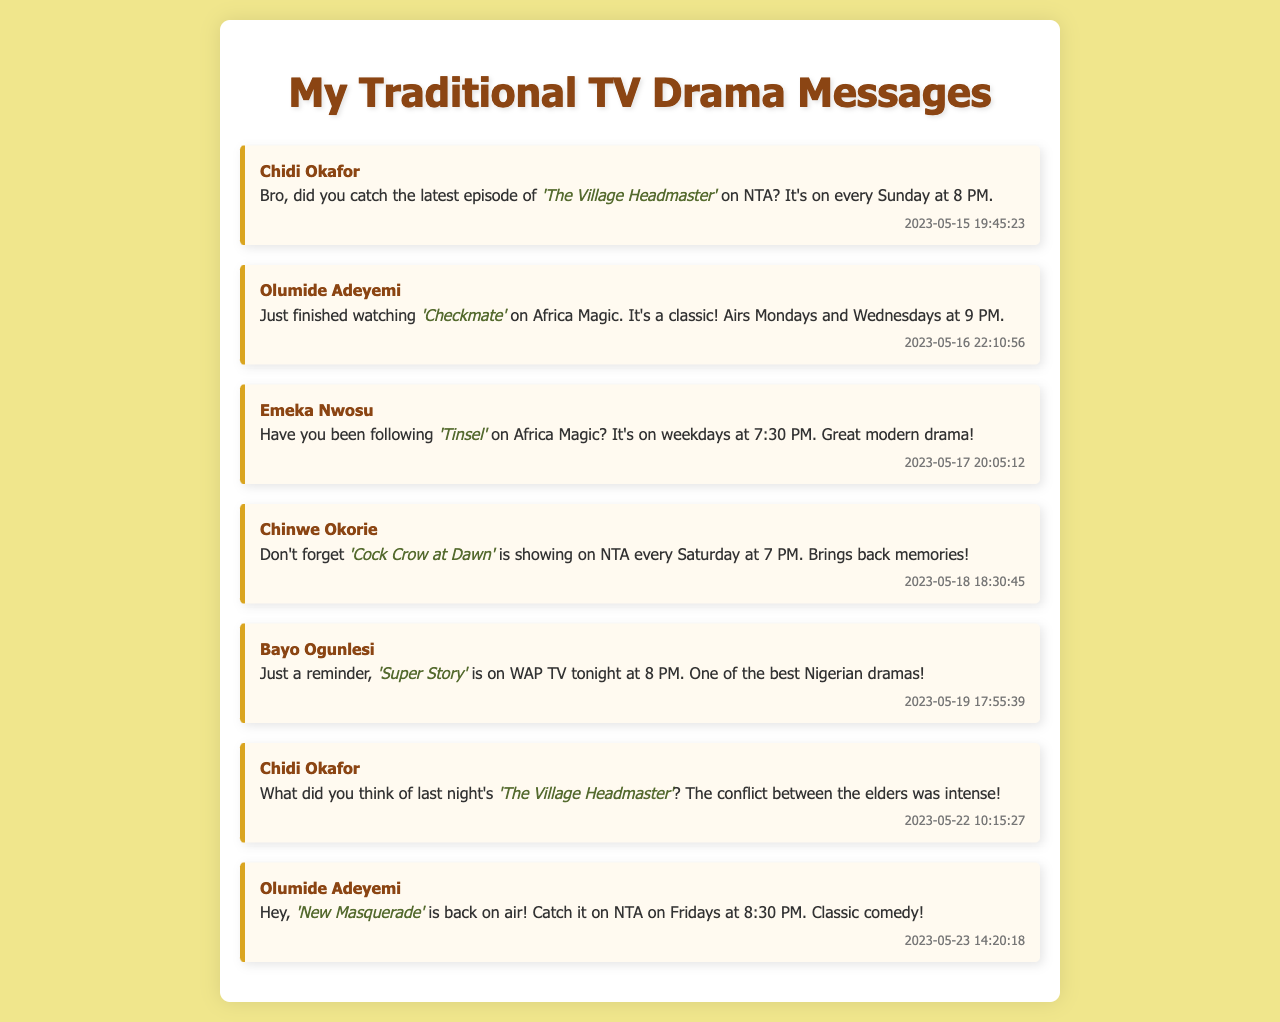What is the name of the drama mentioned by Chidi Okafor? Chidi Okafor mentioned the drama 'The Village Headmaster'.
Answer: 'The Village Headmaster' When does 'Checkmate' air? 'Checkmate' airs on Mondays and Wednesdays at 9 PM according to Olumide Adeyemi.
Answer: Mondays and Wednesdays at 9 PM Who recommended 'Tinsel'? Emeka Nwosu recommended 'Tinsel'.
Answer: Emeka Nwosu On which channel is 'Cock Crow at Dawn' shown? 'Cock Crow at Dawn' is shown on NTA according to Chinwe Okorie.
Answer: NTA What is the air time for 'Super Story'? 'Super Story' is on WAP TV at 8 PM as reminded by Bayo Ogunlesi.
Answer: 8 PM Which friend mentioned 'New Masquerade'? Olumide Adeyemi mentioned 'New Masquerade'.
Answer: Olumide Adeyemi What day of the week does 'The Village Headmaster' air? 'The Village Headmaster' airs on Sunday according to Chidi Okafor.
Answer: Sunday How many messages did Chidi Okafor send? Chidi Okafor sent 2 messages in total.
Answer: 2 What is the date of Emeka Nwosu's message? Emeka Nwosu's message was sent on May 17, 2023.
Answer: May 17, 2023 